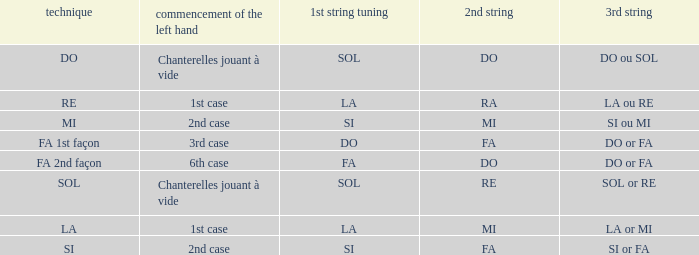What is the initial position of the left hand for ra's 2nd string? 1st case. 